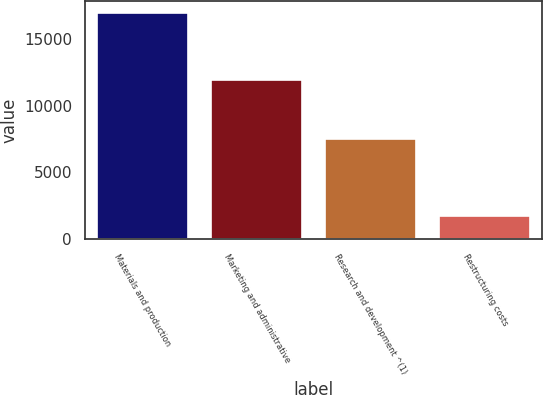<chart> <loc_0><loc_0><loc_500><loc_500><bar_chart><fcel>Materials and production<fcel>Marketing and administrative<fcel>Research and development ^(1)<fcel>Restructuring costs<nl><fcel>16954<fcel>11911<fcel>7503<fcel>1709<nl></chart> 